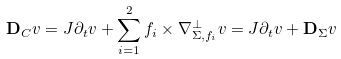Convert formula to latex. <formula><loc_0><loc_0><loc_500><loc_500>\mathbf D _ { C } v & = J \partial _ { t } v + \sum _ { i = 1 } ^ { 2 } f _ { i } \times \nabla _ { \Sigma , f _ { i } } ^ { \perp } v = J \partial _ { t } v + \mathbf D _ { \Sigma } v</formula> 